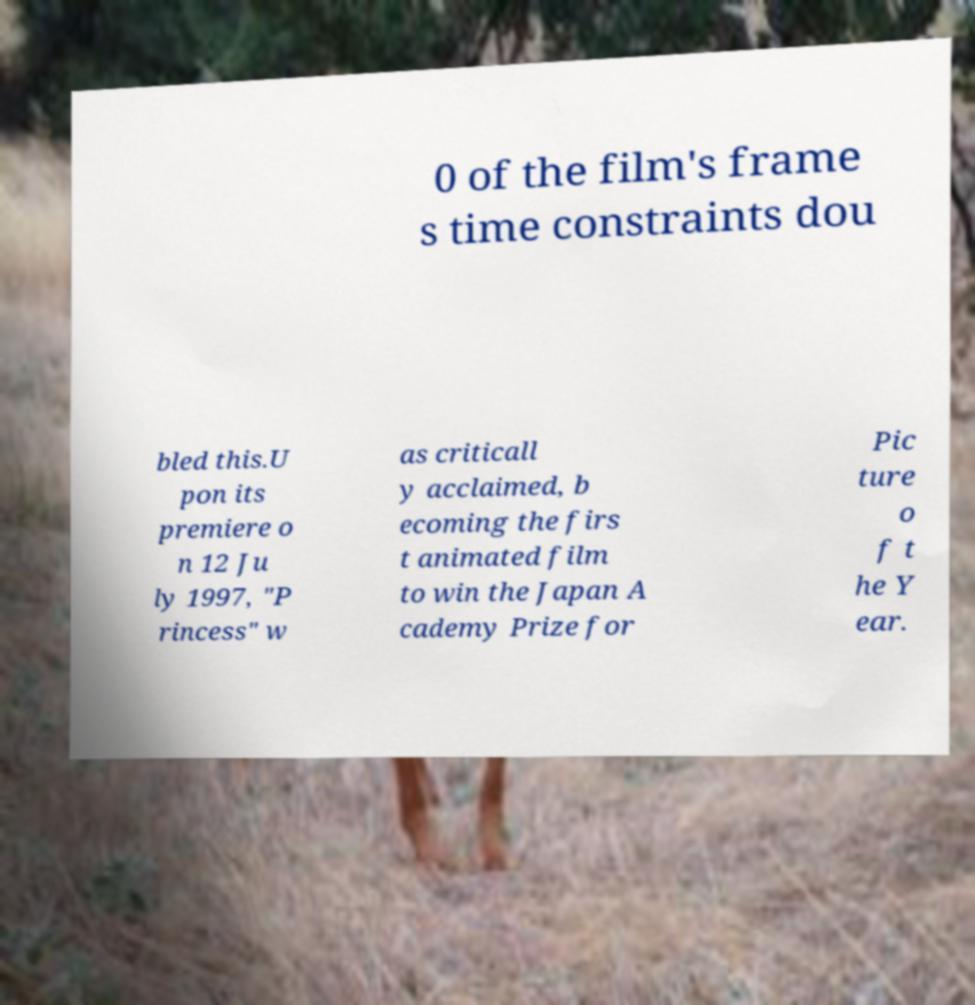Can you read and provide the text displayed in the image?This photo seems to have some interesting text. Can you extract and type it out for me? 0 of the film's frame s time constraints dou bled this.U pon its premiere o n 12 Ju ly 1997, "P rincess" w as criticall y acclaimed, b ecoming the firs t animated film to win the Japan A cademy Prize for Pic ture o f t he Y ear. 